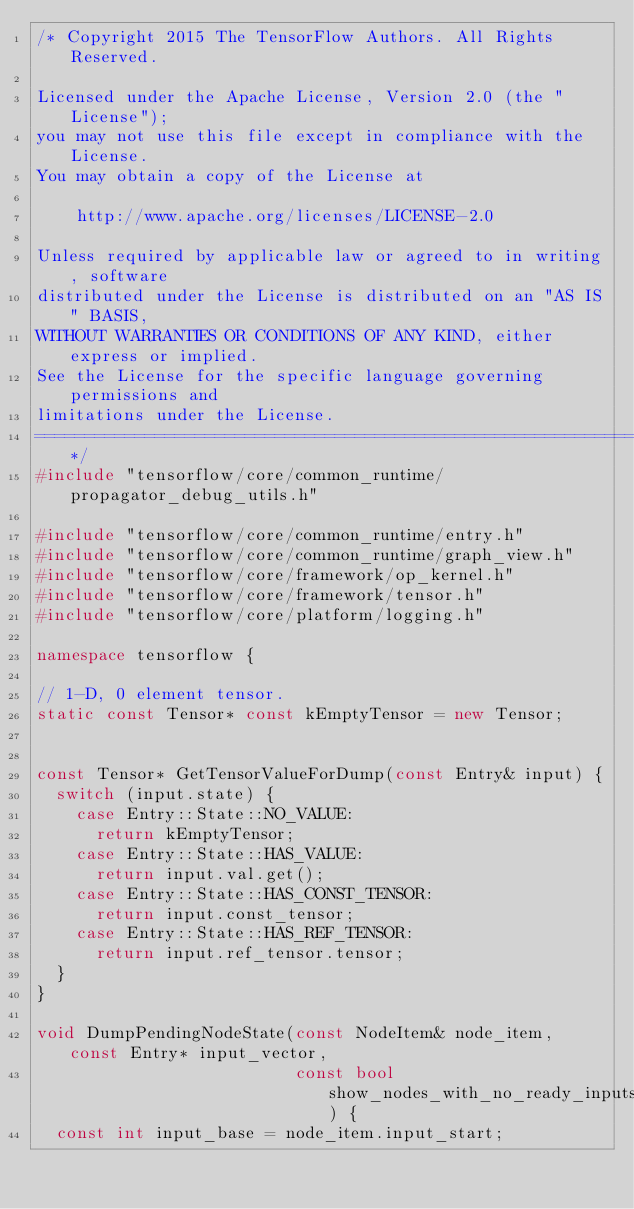<code> <loc_0><loc_0><loc_500><loc_500><_C++_>/* Copyright 2015 The TensorFlow Authors. All Rights Reserved.

Licensed under the Apache License, Version 2.0 (the "License");
you may not use this file except in compliance with the License.
You may obtain a copy of the License at

    http://www.apache.org/licenses/LICENSE-2.0

Unless required by applicable law or agreed to in writing, software
distributed under the License is distributed on an "AS IS" BASIS,
WITHOUT WARRANTIES OR CONDITIONS OF ANY KIND, either express or implied.
See the License for the specific language governing permissions and
limitations under the License.
==============================================================================*/
#include "tensorflow/core/common_runtime/propagator_debug_utils.h"

#include "tensorflow/core/common_runtime/entry.h"
#include "tensorflow/core/common_runtime/graph_view.h"
#include "tensorflow/core/framework/op_kernel.h"
#include "tensorflow/core/framework/tensor.h"
#include "tensorflow/core/platform/logging.h"

namespace tensorflow {

// 1-D, 0 element tensor.
static const Tensor* const kEmptyTensor = new Tensor;


const Tensor* GetTensorValueForDump(const Entry& input) {
  switch (input.state) {
    case Entry::State::NO_VALUE:
      return kEmptyTensor;
    case Entry::State::HAS_VALUE:
      return input.val.get();
    case Entry::State::HAS_CONST_TENSOR:
      return input.const_tensor;
    case Entry::State::HAS_REF_TENSOR:
      return input.ref_tensor.tensor;
  }
}

void DumpPendingNodeState(const NodeItem& node_item, const Entry* input_vector,
                          const bool show_nodes_with_no_ready_inputs) {
  const int input_base = node_item.input_start;</code> 